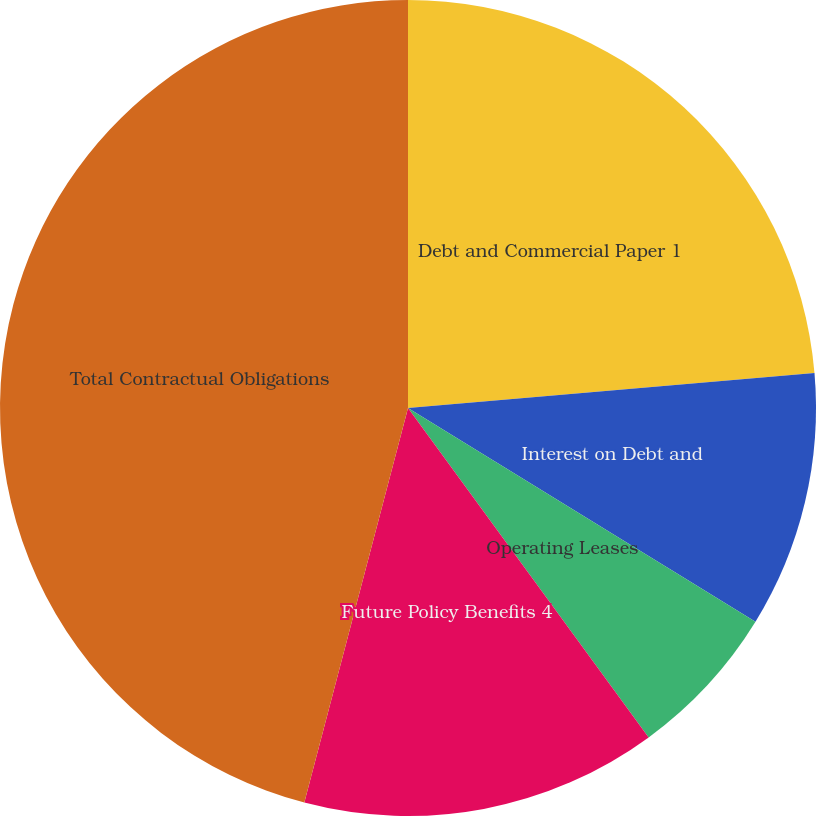<chart> <loc_0><loc_0><loc_500><loc_500><pie_chart><fcel>Debt and Commercial Paper 1<fcel>Interest on Debt and<fcel>Operating Leases<fcel>Future Policy Benefits 4<fcel>Total Contractual Obligations<nl><fcel>23.63%<fcel>10.15%<fcel>6.18%<fcel>14.13%<fcel>45.91%<nl></chart> 